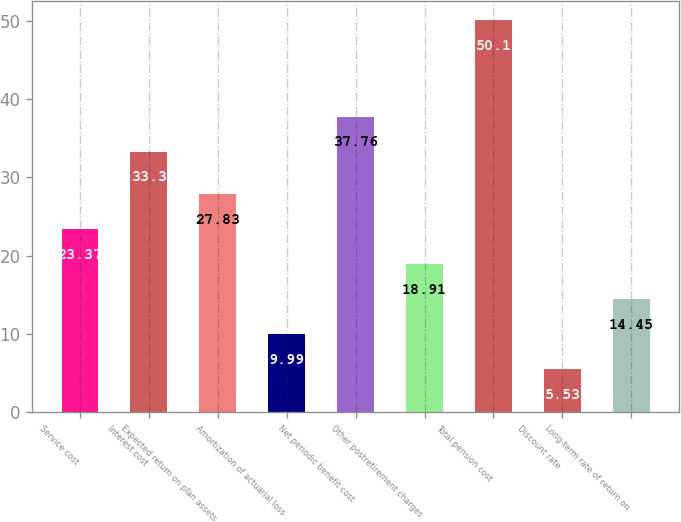<chart> <loc_0><loc_0><loc_500><loc_500><bar_chart><fcel>Service cost<fcel>Interest cost<fcel>Expected return on plan assets<fcel>Amortization of actuarial loss<fcel>Net periodic benefit cost<fcel>Other postretirement charges<fcel>Total pension cost<fcel>Discount rate<fcel>Long-term rate of return on<nl><fcel>23.37<fcel>33.3<fcel>27.83<fcel>9.99<fcel>37.76<fcel>18.91<fcel>50.1<fcel>5.53<fcel>14.45<nl></chart> 